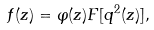Convert formula to latex. <formula><loc_0><loc_0><loc_500><loc_500>f ( z ) = \varphi ( z ) F [ q ^ { 2 } ( z ) ] ,</formula> 